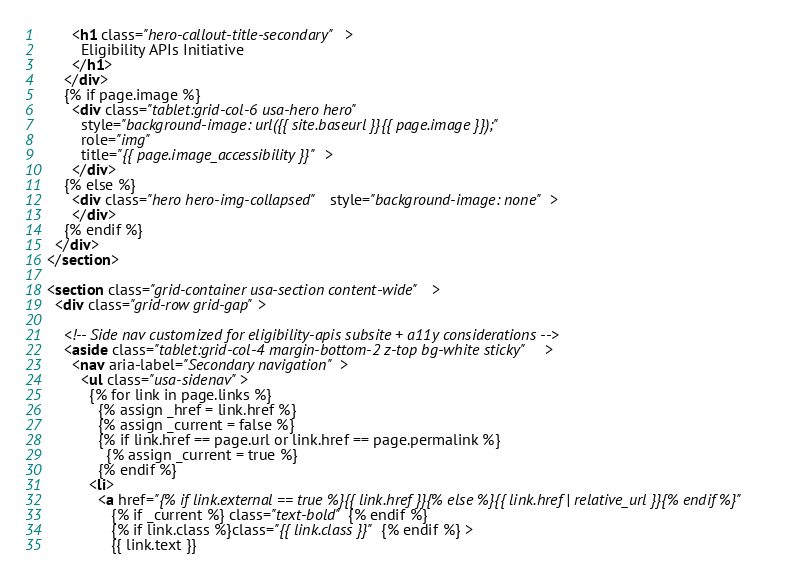<code> <loc_0><loc_0><loc_500><loc_500><_HTML_>        <h1 class="hero-callout-title-secondary">
          Eligibility APIs Initiative
        </h1>
      </div>
      {% if page.image %}
        <div class="tablet:grid-col-6 usa-hero hero"
          style="background-image: url({{ site.baseurl }}{{ page.image }});"
          role="img"
          title="{{ page.image_accessibility }}">
        </div>
      {% else %}
        <div class="hero hero-img-collapsed" style="background-image: none">
        </div>
      {% endif %}
    </div>
  </section>

  <section class="grid-container usa-section content-wide">
    <div class="grid-row grid-gap">

      <!-- Side nav customized for eligibility-apis subsite + a11y considerations -->
      <aside class="tablet:grid-col-4 margin-bottom-2 z-top bg-white sticky">
        <nav aria-label="Secondary navigation">
          <ul class="usa-sidenav">
            {% for link in page.links %}
              {% assign _href = link.href %}
              {% assign _current = false %}
              {% if link.href == page.url or link.href == page.permalink %}
                {% assign _current = true %}
              {% endif %}
            <li>
              <a href="{% if link.external == true %}{{ link.href }}{% else %}{{ link.href | relative_url }}{% endif %}"
                 {% if _current %} class="text-bold" {% endif %}
                 {% if link.class %}class="{{ link.class }}" {% endif %} >
                 {{ link.text }}</code> 